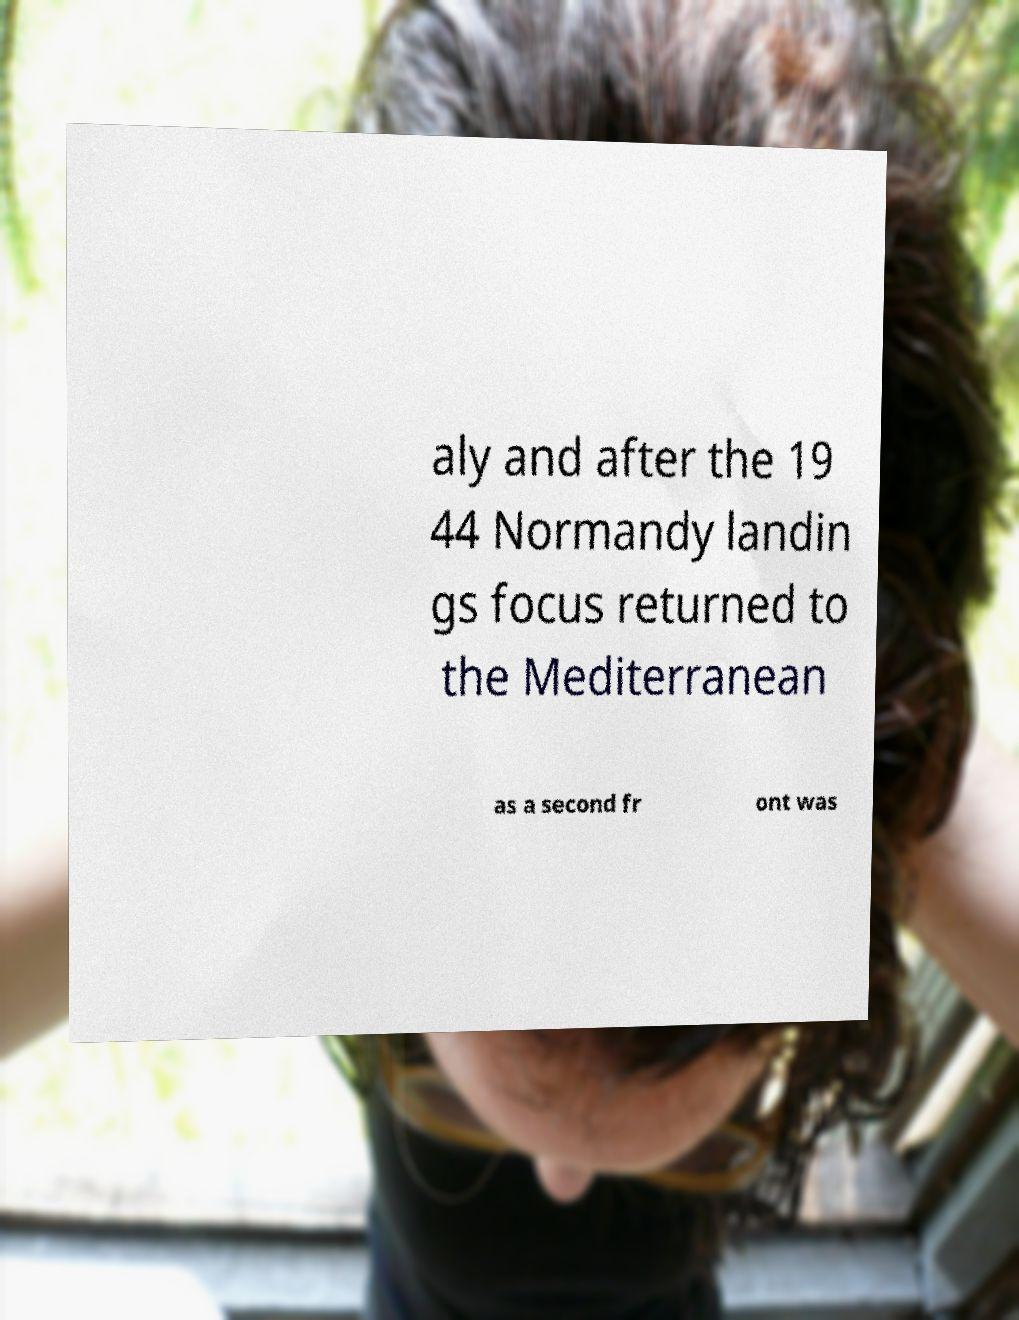Please identify and transcribe the text found in this image. aly and after the 19 44 Normandy landin gs focus returned to the Mediterranean as a second fr ont was 